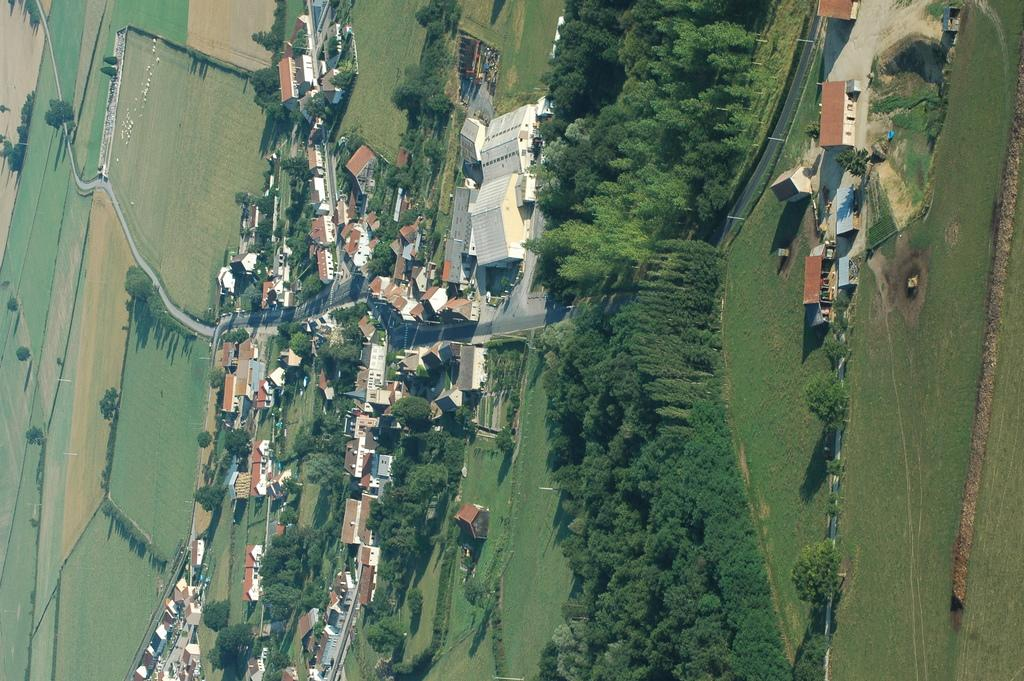What type of view is shown in the image? The image is an aerial view of a city. What can be seen on the ground in the image? There is ground visible in the image. What type of vegetation is present in the image? There are trees in the image. What type of infrastructure can be seen in the image? There are roads and buildings in the image. What natural feature is visible in the image? There is water visible in the image. What type of bait is being used to catch fish in the image? There is no fishing or bait present in the image; it is an aerial view of a city. What type of apparel is being worn by the people in the image? There are no people visible in the image, only buildings, roads, trees, and water. 